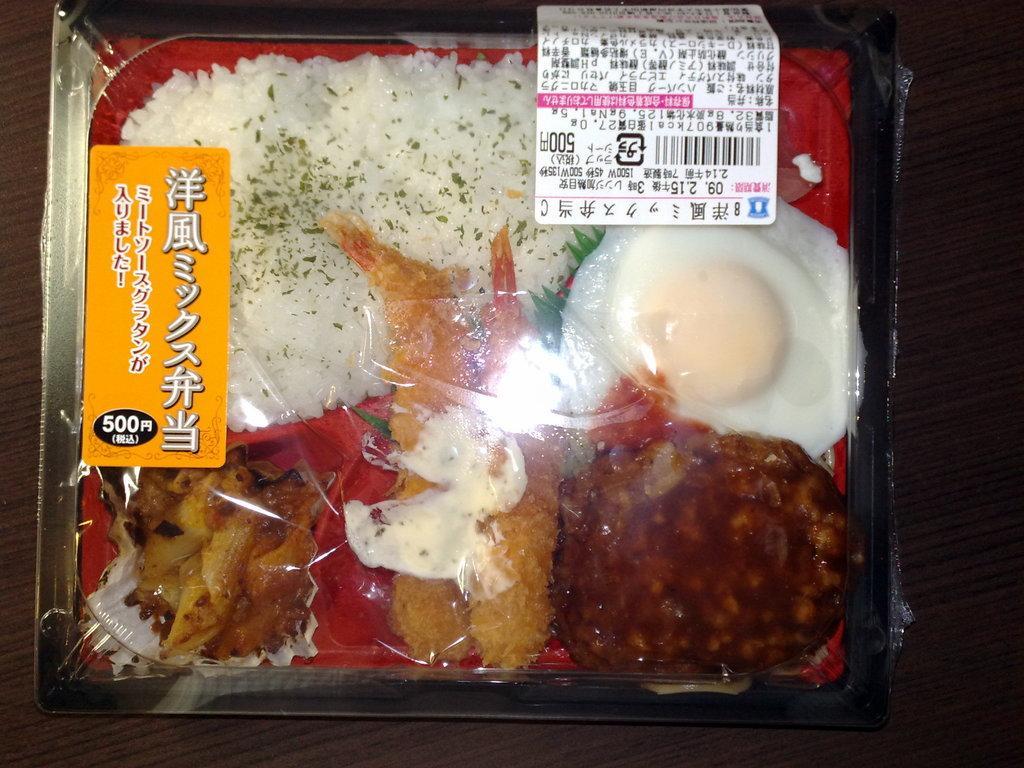Please provide a concise description of this image. In this picture we can see a bowl on the wooden object and in the bowl there are some food items and the box is covered with a plastic cover. On the cover there are some labels. 